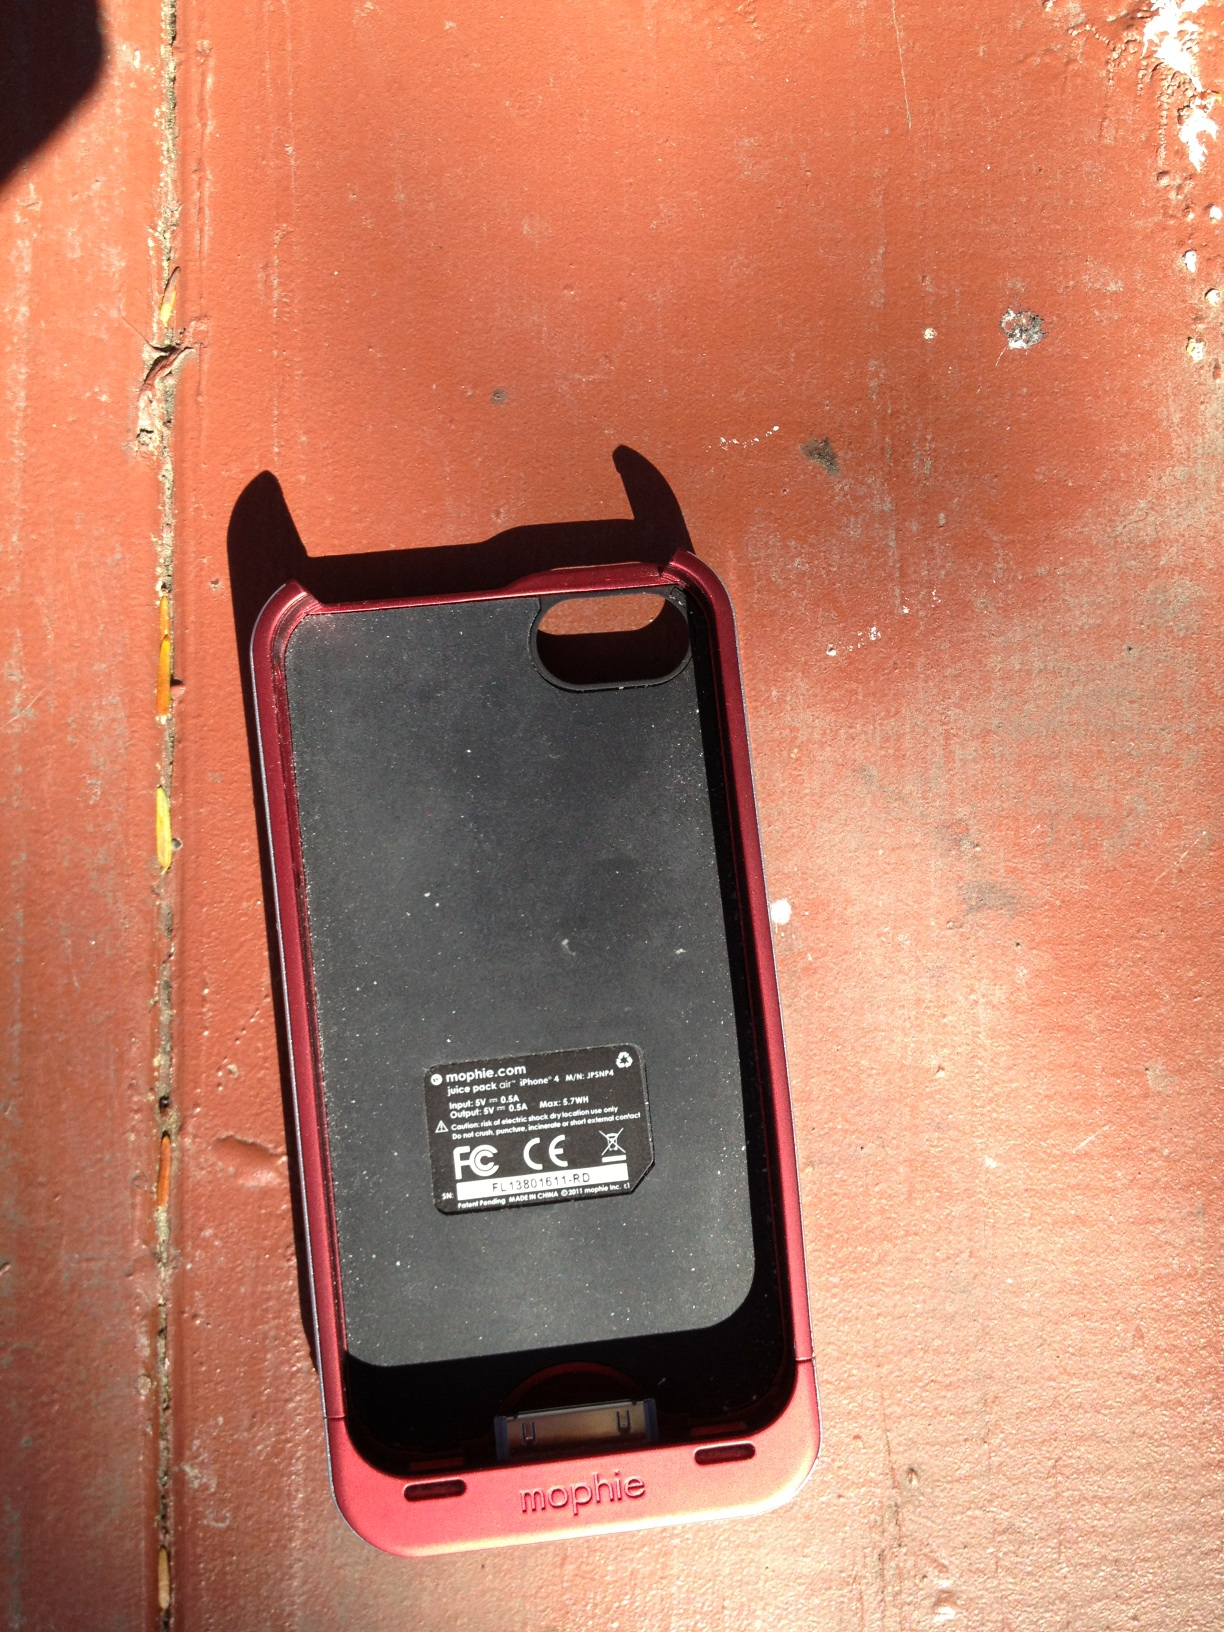What is this object? This object is a Mophie battery pack case for a smartphone, designed not only to protect your device but to provide additional battery life. It's particularly useful for extending phone usage during travel or long days away from power sources. 